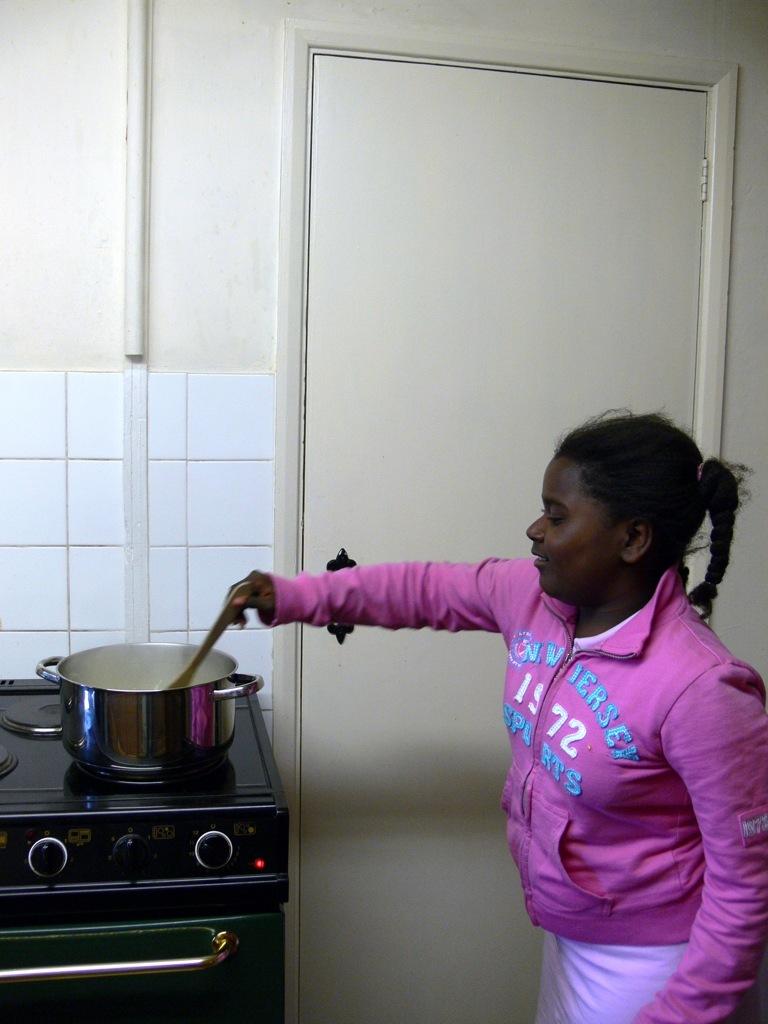What is the year on the hoodie?
Give a very brief answer. 1972. What state is on the jacket?
Your response must be concise. New jersey. 